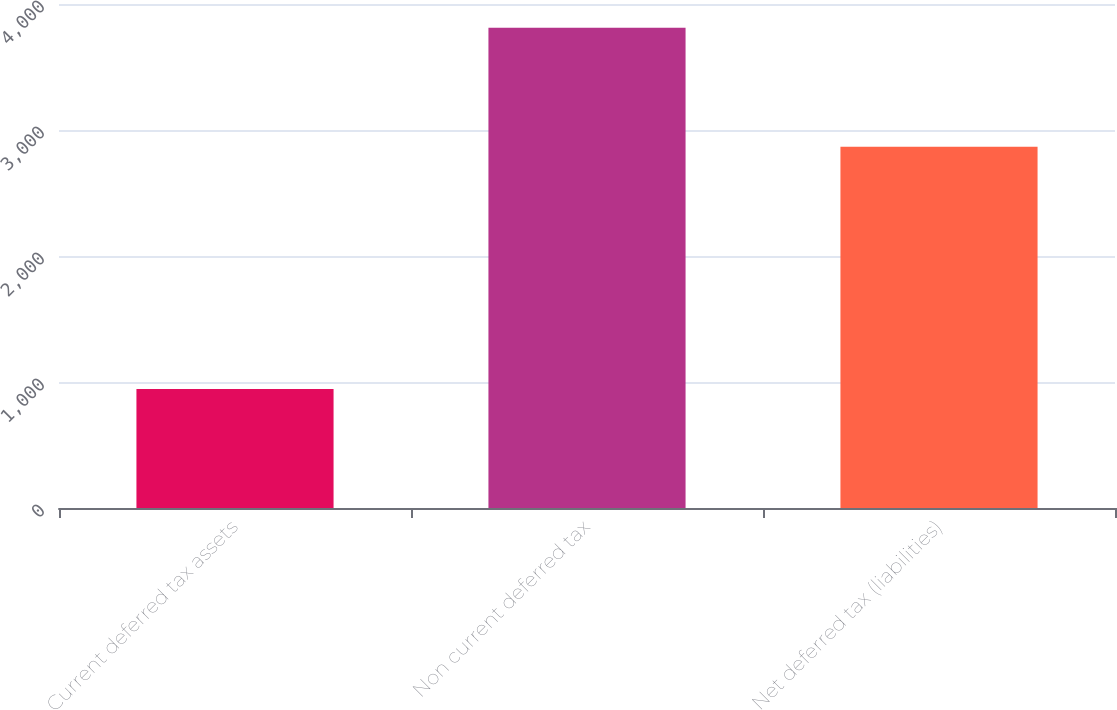Convert chart. <chart><loc_0><loc_0><loc_500><loc_500><bar_chart><fcel>Current deferred tax assets<fcel>Non current deferred tax<fcel>Net deferred tax (liabilities)<nl><fcel>944<fcel>3811<fcel>2867<nl></chart> 